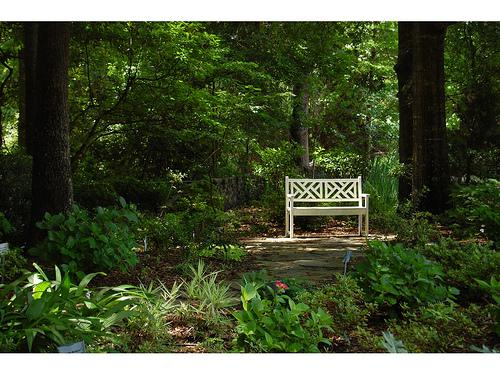Question: who is sitting on the bench?
Choices:
A. A child.
B. No one.
C. Two men.
D. Two women.
Answer with the letter. Answer: B Question: what color are the trees?
Choices:
A. Orange.
B. Red.
C. Yellow.
D. Green.
Answer with the letter. Answer: D Question: when was this picture taken?
Choices:
A. Evening.
B. Nighttime.
C. Twilight.
D. During the day.
Answer with the letter. Answer: D Question: why is the bench in a forest?
Choices:
A. For rest.
B. For the people walking the trail.
C. For the campers.
D. So people can sit on it.
Answer with the letter. Answer: D Question: where is the sunlight coming from?
Choices:
A. Through the trees.
B. The window.
C. The sky.
D. Through the clouds.
Answer with the letter. Answer: A 